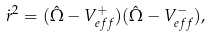<formula> <loc_0><loc_0><loc_500><loc_500>\dot { r } ^ { 2 } = ( \hat { \Omega } - V ^ { + } _ { e f f } ) ( \hat { \Omega } - V ^ { - } _ { e f f } ) ,</formula> 